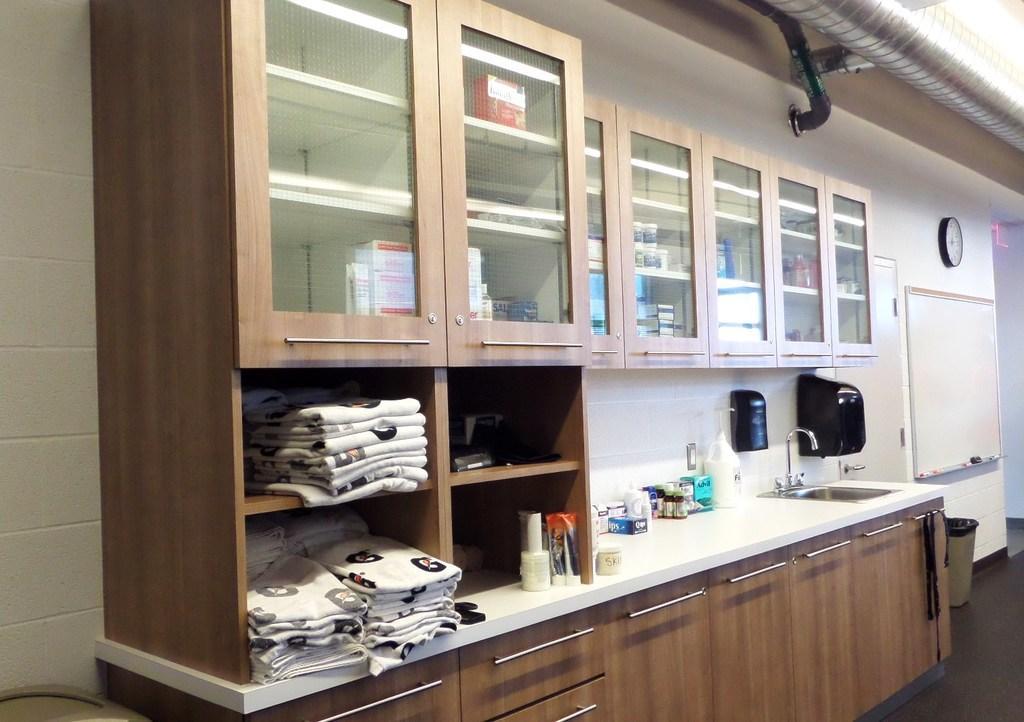Please provide a concise description of this image. In this picture there are cupboards at the top and bottom side of the image and there is a sink on the right side of the image, there is a rack on the left side of the image, in which there are clothes. 